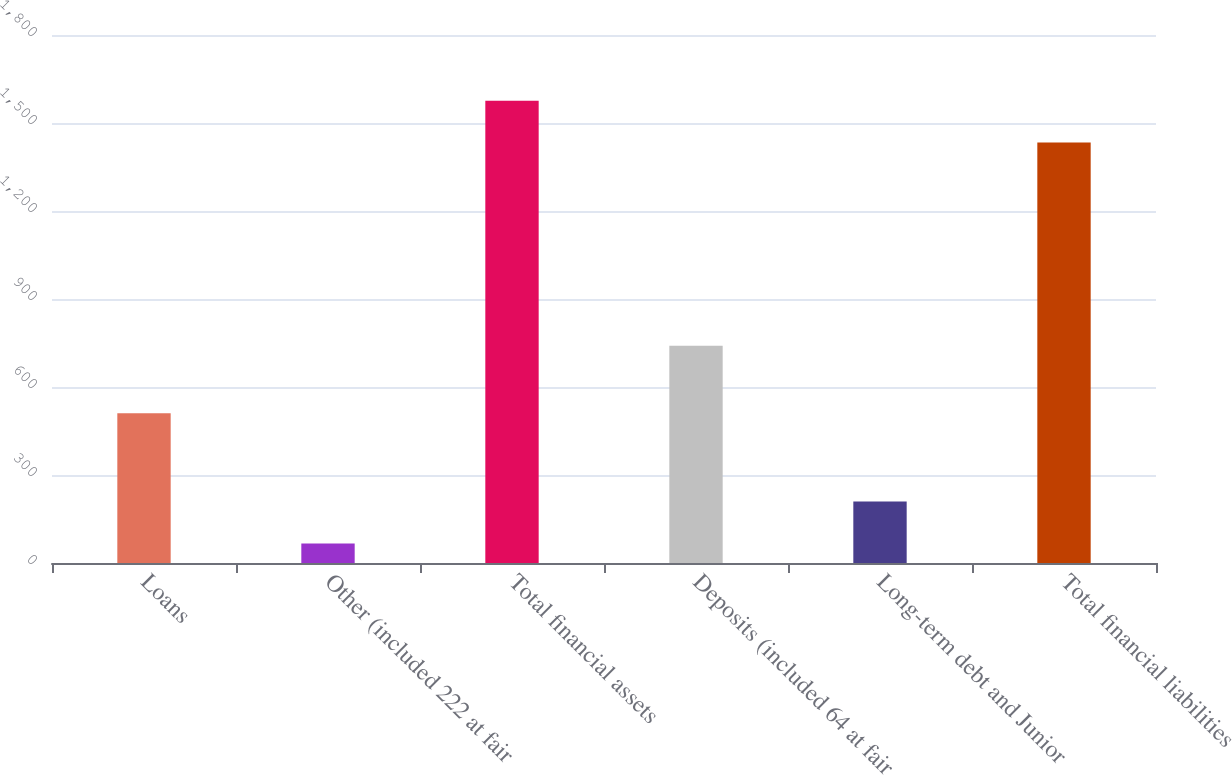Convert chart to OTSL. <chart><loc_0><loc_0><loc_500><loc_500><bar_chart><fcel>Loans<fcel>Other (included 222 at fair<fcel>Total financial assets<fcel>Deposits (included 64 at fair<fcel>Long-term debt and Junior<fcel>Total financial liabilities<nl><fcel>510.1<fcel>66.6<fcel>1576.1<fcel>740.7<fcel>209.3<fcel>1433.4<nl></chart> 